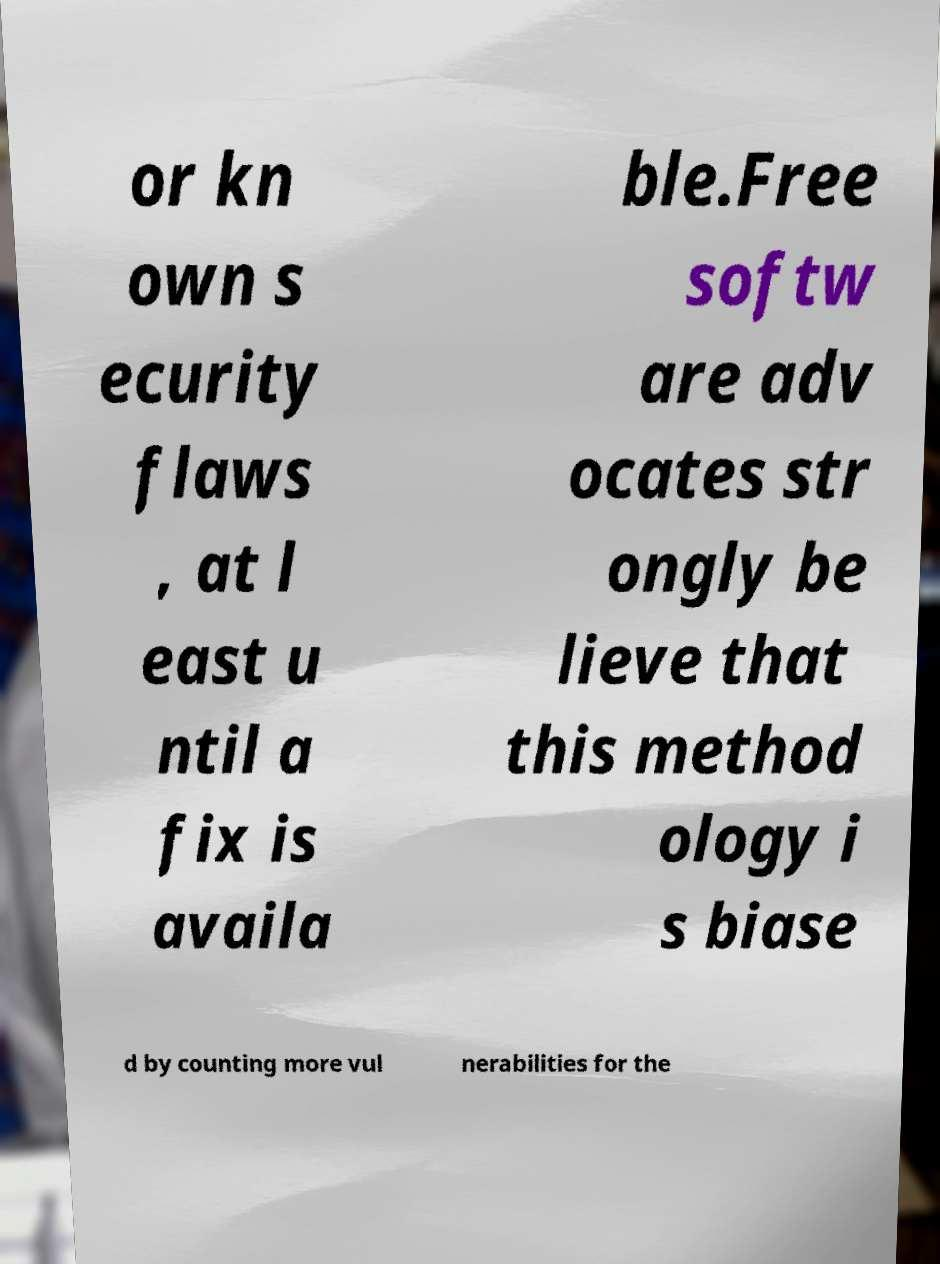Please read and relay the text visible in this image. What does it say? or kn own s ecurity flaws , at l east u ntil a fix is availa ble.Free softw are adv ocates str ongly be lieve that this method ology i s biase d by counting more vul nerabilities for the 